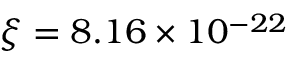Convert formula to latex. <formula><loc_0><loc_0><loc_500><loc_500>\xi = 8 . 1 6 \times 1 0 ^ { - 2 2 }</formula> 